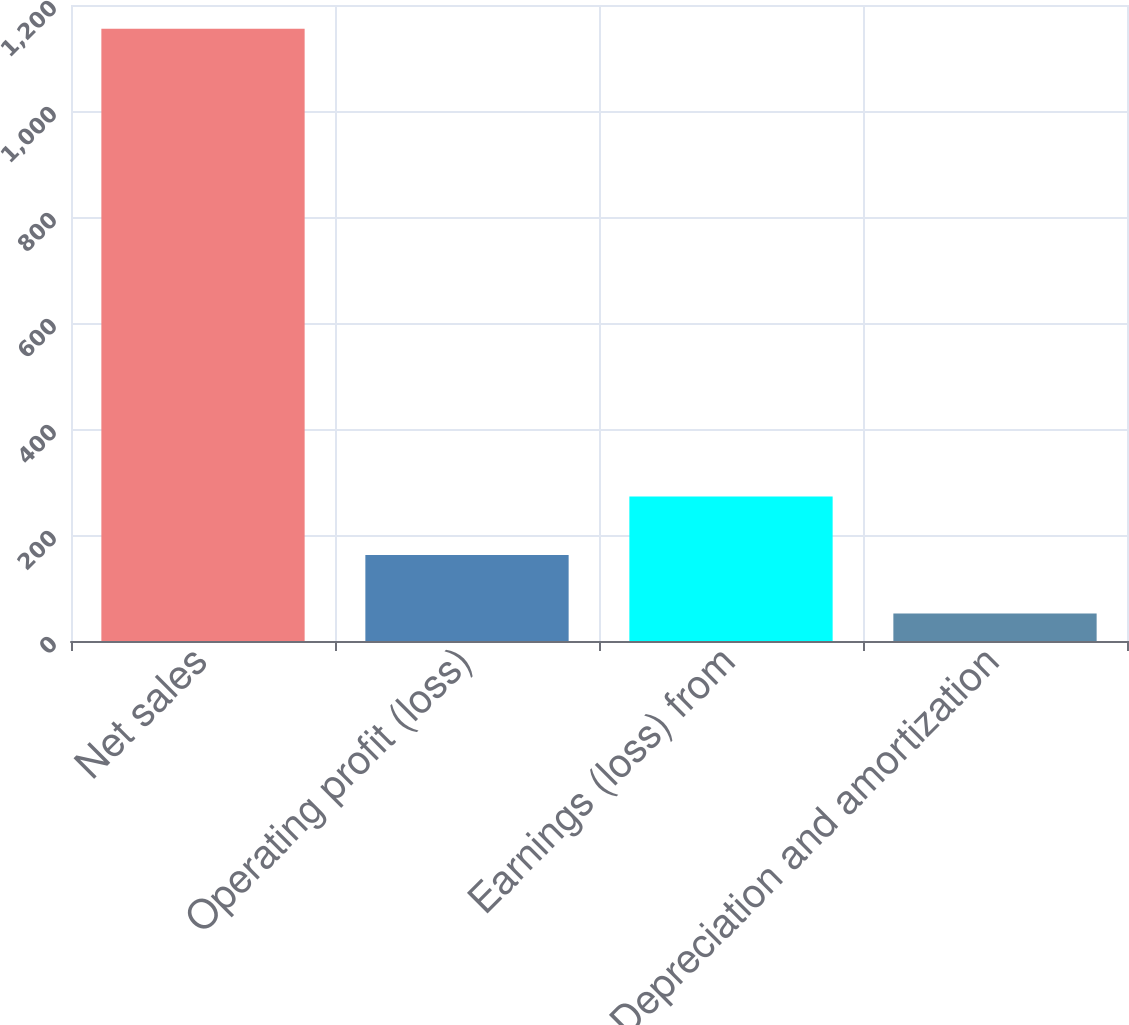Convert chart. <chart><loc_0><loc_0><loc_500><loc_500><bar_chart><fcel>Net sales<fcel>Operating profit (loss)<fcel>Earnings (loss) from<fcel>Depreciation and amortization<nl><fcel>1155<fcel>162.3<fcel>272.6<fcel>52<nl></chart> 